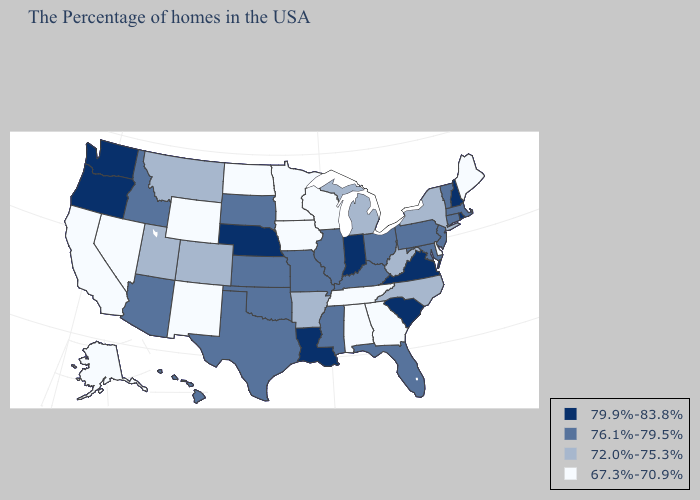What is the value of Colorado?
Give a very brief answer. 72.0%-75.3%. What is the value of Iowa?
Short answer required. 67.3%-70.9%. Name the states that have a value in the range 72.0%-75.3%?
Answer briefly. New York, North Carolina, West Virginia, Michigan, Arkansas, Colorado, Utah, Montana. Name the states that have a value in the range 76.1%-79.5%?
Quick response, please. Massachusetts, Vermont, Connecticut, New Jersey, Maryland, Pennsylvania, Ohio, Florida, Kentucky, Illinois, Mississippi, Missouri, Kansas, Oklahoma, Texas, South Dakota, Arizona, Idaho, Hawaii. What is the lowest value in the West?
Quick response, please. 67.3%-70.9%. Does Missouri have the highest value in the USA?
Short answer required. No. What is the lowest value in the USA?
Be succinct. 67.3%-70.9%. Does New Hampshire have a higher value than Missouri?
Quick response, please. Yes. Name the states that have a value in the range 76.1%-79.5%?
Short answer required. Massachusetts, Vermont, Connecticut, New Jersey, Maryland, Pennsylvania, Ohio, Florida, Kentucky, Illinois, Mississippi, Missouri, Kansas, Oklahoma, Texas, South Dakota, Arizona, Idaho, Hawaii. Name the states that have a value in the range 67.3%-70.9%?
Concise answer only. Maine, Delaware, Georgia, Alabama, Tennessee, Wisconsin, Minnesota, Iowa, North Dakota, Wyoming, New Mexico, Nevada, California, Alaska. What is the value of Nebraska?
Short answer required. 79.9%-83.8%. Does Georgia have the lowest value in the USA?
Be succinct. Yes. What is the value of Georgia?
Short answer required. 67.3%-70.9%. What is the highest value in the West ?
Concise answer only. 79.9%-83.8%. Is the legend a continuous bar?
Be succinct. No. 